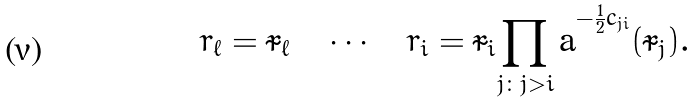<formula> <loc_0><loc_0><loc_500><loc_500>r _ { \ell } = \tilde { r } _ { \ell } \quad \cdots \quad r _ { i } = \tilde { r } _ { i } { \prod _ { j \colon j > i } { \text {a} } } ^ { - \frac { 1 } { 2 } c _ { j i } } ( \tilde { r } _ { j } ) .</formula> 